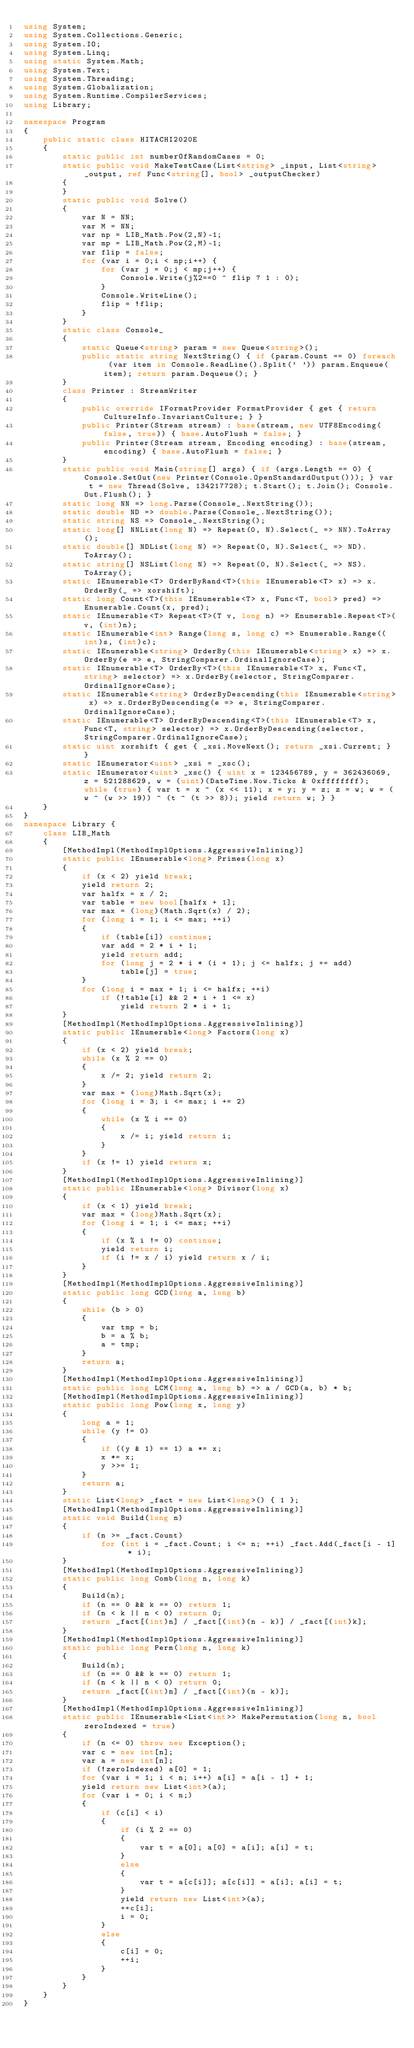Convert code to text. <code><loc_0><loc_0><loc_500><loc_500><_C#_>using System;
using System.Collections.Generic;
using System.IO;
using System.Linq;
using static System.Math;
using System.Text;
using System.Threading;
using System.Globalization;
using System.Runtime.CompilerServices;
using Library;

namespace Program
{
    public static class HITACHI2020E
    {
        static public int numberOfRandomCases = 0;
        static public void MakeTestCase(List<string> _input, List<string> _output, ref Func<string[], bool> _outputChecker)
        {
        }
        static public void Solve()
        {
            var N = NN;
            var M = NN;
            var np = LIB_Math.Pow(2,N)-1;
            var mp = LIB_Math.Pow(2,M)-1;
            var flip = false;
            for (var i = 0;i < np;i++) {
                for (var j = 0;j < mp;j++) {
                    Console.Write(j%2==0 ^ flip ? 1 : 0);
                }
                Console.WriteLine();
                flip = !flip;
            }
        }
        static class Console_
        {
            static Queue<string> param = new Queue<string>();
            public static string NextString() { if (param.Count == 0) foreach (var item in Console.ReadLine().Split(' ')) param.Enqueue(item); return param.Dequeue(); }
        }
        class Printer : StreamWriter
        {
            public override IFormatProvider FormatProvider { get { return CultureInfo.InvariantCulture; } }
            public Printer(Stream stream) : base(stream, new UTF8Encoding(false, true)) { base.AutoFlush = false; }
            public Printer(Stream stream, Encoding encoding) : base(stream, encoding) { base.AutoFlush = false; }
        }
        static public void Main(string[] args) { if (args.Length == 0) { Console.SetOut(new Printer(Console.OpenStandardOutput())); } var t = new Thread(Solve, 134217728); t.Start(); t.Join(); Console.Out.Flush(); }
        static long NN => long.Parse(Console_.NextString());
        static double ND => double.Parse(Console_.NextString());
        static string NS => Console_.NextString();
        static long[] NNList(long N) => Repeat(0, N).Select(_ => NN).ToArray();
        static double[] NDList(long N) => Repeat(0, N).Select(_ => ND).ToArray();
        static string[] NSList(long N) => Repeat(0, N).Select(_ => NS).ToArray();
        static IEnumerable<T> OrderByRand<T>(this IEnumerable<T> x) => x.OrderBy(_ => xorshift);
        static long Count<T>(this IEnumerable<T> x, Func<T, bool> pred) => Enumerable.Count(x, pred);
        static IEnumerable<T> Repeat<T>(T v, long n) => Enumerable.Repeat<T>(v, (int)n);
        static IEnumerable<int> Range(long s, long c) => Enumerable.Range((int)s, (int)c);
        static IEnumerable<string> OrderBy(this IEnumerable<string> x) => x.OrderBy(e => e, StringComparer.OrdinalIgnoreCase);
        static IEnumerable<T> OrderBy<T>(this IEnumerable<T> x, Func<T, string> selector) => x.OrderBy(selector, StringComparer.OrdinalIgnoreCase);
        static IEnumerable<string> OrderByDescending(this IEnumerable<string> x) => x.OrderByDescending(e => e, StringComparer.OrdinalIgnoreCase);
        static IEnumerable<T> OrderByDescending<T>(this IEnumerable<T> x, Func<T, string> selector) => x.OrderByDescending(selector, StringComparer.OrdinalIgnoreCase);
        static uint xorshift { get { _xsi.MoveNext(); return _xsi.Current; } }
        static IEnumerator<uint> _xsi = _xsc();
        static IEnumerator<uint> _xsc() { uint x = 123456789, y = 362436069, z = 521288629, w = (uint)(DateTime.Now.Ticks & 0xffffffff); while (true) { var t = x ^ (x << 11); x = y; y = z; z = w; w = (w ^ (w >> 19)) ^ (t ^ (t >> 8)); yield return w; } }
    }
}
namespace Library {
    class LIB_Math
    {
        [MethodImpl(MethodImplOptions.AggressiveInlining)]
        static public IEnumerable<long> Primes(long x)
        {
            if (x < 2) yield break;
            yield return 2;
            var halfx = x / 2;
            var table = new bool[halfx + 1];
            var max = (long)(Math.Sqrt(x) / 2);
            for (long i = 1; i <= max; ++i)
            {
                if (table[i]) continue;
                var add = 2 * i + 1;
                yield return add;
                for (long j = 2 * i * (i + 1); j <= halfx; j += add)
                    table[j] = true;
            }
            for (long i = max + 1; i <= halfx; ++i)
                if (!table[i] && 2 * i + 1 <= x)
                    yield return 2 * i + 1;
        }
        [MethodImpl(MethodImplOptions.AggressiveInlining)]
        static public IEnumerable<long> Factors(long x)
        {
            if (x < 2) yield break;
            while (x % 2 == 0)
            {
                x /= 2; yield return 2;
            }
            var max = (long)Math.Sqrt(x);
            for (long i = 3; i <= max; i += 2)
            {
                while (x % i == 0)
                {
                    x /= i; yield return i;
                }
            }
            if (x != 1) yield return x;
        }
        [MethodImpl(MethodImplOptions.AggressiveInlining)]
        static public IEnumerable<long> Divisor(long x)
        {
            if (x < 1) yield break;
            var max = (long)Math.Sqrt(x);
            for (long i = 1; i <= max; ++i)
            {
                if (x % i != 0) continue;
                yield return i;
                if (i != x / i) yield return x / i;
            }
        }
        [MethodImpl(MethodImplOptions.AggressiveInlining)]
        static public long GCD(long a, long b)
        {
            while (b > 0)
            {
                var tmp = b;
                b = a % b;
                a = tmp;
            }
            return a;
        }
        [MethodImpl(MethodImplOptions.AggressiveInlining)]
        static public long LCM(long a, long b) => a / GCD(a, b) * b;
        [MethodImpl(MethodImplOptions.AggressiveInlining)]
        static public long Pow(long x, long y)
        {
            long a = 1;
            while (y != 0)
            {
                if ((y & 1) == 1) a *= x;
                x *= x;
                y >>= 1;
            }
            return a;
        }
        static List<long> _fact = new List<long>() { 1 };
        [MethodImpl(MethodImplOptions.AggressiveInlining)]
        static void Build(long n)
        {
            if (n >= _fact.Count)
                for (int i = _fact.Count; i <= n; ++i) _fact.Add(_fact[i - 1] * i);
        }
        [MethodImpl(MethodImplOptions.AggressiveInlining)]
        static public long Comb(long n, long k)
        {
            Build(n);
            if (n == 0 && k == 0) return 1;
            if (n < k || n < 0) return 0;
            return _fact[(int)n] / _fact[(int)(n - k)] / _fact[(int)k];
        }
        [MethodImpl(MethodImplOptions.AggressiveInlining)]
        static public long Perm(long n, long k)
        {
            Build(n);
            if (n == 0 && k == 0) return 1;
            if (n < k || n < 0) return 0;
            return _fact[(int)n] / _fact[(int)(n - k)];
        }
        [MethodImpl(MethodImplOptions.AggressiveInlining)]
        static public IEnumerable<List<int>> MakePermutation(long n, bool zeroIndexed = true)
        {
            if (n <= 0) throw new Exception();
            var c = new int[n];
            var a = new int[n];
            if (!zeroIndexed) a[0] = 1;
            for (var i = 1; i < n; i++) a[i] = a[i - 1] + 1;
            yield return new List<int>(a);
            for (var i = 0; i < n;)
            {
                if (c[i] < i)
                {
                    if (i % 2 == 0)
                    {
                        var t = a[0]; a[0] = a[i]; a[i] = t;
                    }
                    else
                    {
                        var t = a[c[i]]; a[c[i]] = a[i]; a[i] = t;
                    }
                    yield return new List<int>(a);
                    ++c[i];
                    i = 0;
                }
                else
                {
                    c[i] = 0;
                    ++i;
                }
            }
        }
    }
}
</code> 